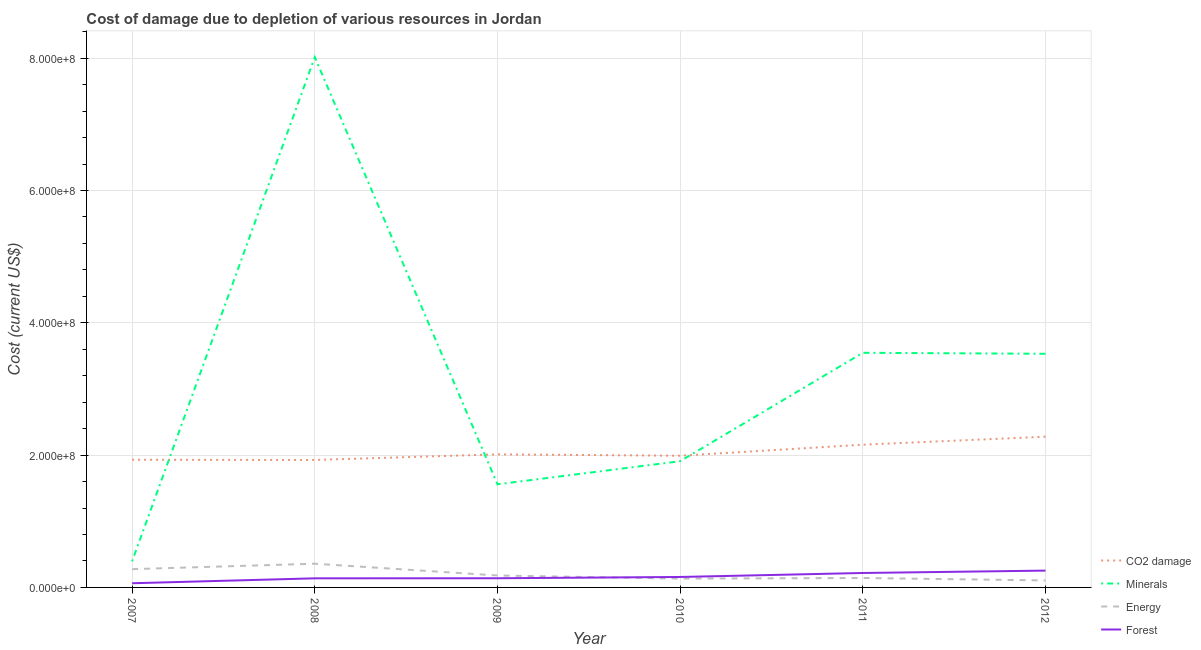Is the number of lines equal to the number of legend labels?
Your answer should be very brief. Yes. What is the cost of damage due to depletion of coal in 2010?
Keep it short and to the point. 1.99e+08. Across all years, what is the maximum cost of damage due to depletion of energy?
Your response must be concise. 3.58e+07. Across all years, what is the minimum cost of damage due to depletion of minerals?
Provide a succinct answer. 3.95e+07. What is the total cost of damage due to depletion of minerals in the graph?
Your answer should be very brief. 1.90e+09. What is the difference between the cost of damage due to depletion of forests in 2011 and that in 2012?
Provide a succinct answer. -3.59e+06. What is the difference between the cost of damage due to depletion of energy in 2009 and the cost of damage due to depletion of coal in 2008?
Provide a short and direct response. -1.75e+08. What is the average cost of damage due to depletion of minerals per year?
Provide a succinct answer. 3.16e+08. In the year 2010, what is the difference between the cost of damage due to depletion of energy and cost of damage due to depletion of coal?
Keep it short and to the point. -1.86e+08. In how many years, is the cost of damage due to depletion of energy greater than 360000000 US$?
Your response must be concise. 0. What is the ratio of the cost of damage due to depletion of energy in 2009 to that in 2012?
Offer a terse response. 1.71. Is the cost of damage due to depletion of minerals in 2009 less than that in 2010?
Offer a very short reply. Yes. Is the difference between the cost of damage due to depletion of coal in 2008 and 2011 greater than the difference between the cost of damage due to depletion of forests in 2008 and 2011?
Offer a very short reply. No. What is the difference between the highest and the second highest cost of damage due to depletion of forests?
Keep it short and to the point. 3.59e+06. What is the difference between the highest and the lowest cost of damage due to depletion of forests?
Your response must be concise. 1.91e+07. Is the sum of the cost of damage due to depletion of minerals in 2007 and 2009 greater than the maximum cost of damage due to depletion of coal across all years?
Give a very brief answer. No. Is the cost of damage due to depletion of energy strictly greater than the cost of damage due to depletion of coal over the years?
Your answer should be compact. No. Is the cost of damage due to depletion of minerals strictly less than the cost of damage due to depletion of forests over the years?
Offer a terse response. No. How many lines are there?
Ensure brevity in your answer.  4. Does the graph contain grids?
Provide a short and direct response. Yes. Where does the legend appear in the graph?
Ensure brevity in your answer.  Bottom right. How many legend labels are there?
Keep it short and to the point. 4. What is the title of the graph?
Provide a succinct answer. Cost of damage due to depletion of various resources in Jordan . What is the label or title of the X-axis?
Provide a short and direct response. Year. What is the label or title of the Y-axis?
Give a very brief answer. Cost (current US$). What is the Cost (current US$) in CO2 damage in 2007?
Ensure brevity in your answer.  1.93e+08. What is the Cost (current US$) of Minerals in 2007?
Provide a succinct answer. 3.95e+07. What is the Cost (current US$) of Energy in 2007?
Your answer should be very brief. 2.76e+07. What is the Cost (current US$) in Forest in 2007?
Provide a short and direct response. 6.30e+06. What is the Cost (current US$) of CO2 damage in 2008?
Your answer should be very brief. 1.93e+08. What is the Cost (current US$) of Minerals in 2008?
Your response must be concise. 8.02e+08. What is the Cost (current US$) of Energy in 2008?
Provide a short and direct response. 3.58e+07. What is the Cost (current US$) in Forest in 2008?
Offer a terse response. 1.38e+07. What is the Cost (current US$) in CO2 damage in 2009?
Ensure brevity in your answer.  2.01e+08. What is the Cost (current US$) of Minerals in 2009?
Provide a short and direct response. 1.56e+08. What is the Cost (current US$) in Energy in 2009?
Ensure brevity in your answer.  1.80e+07. What is the Cost (current US$) of Forest in 2009?
Your response must be concise. 1.39e+07. What is the Cost (current US$) in CO2 damage in 2010?
Keep it short and to the point. 1.99e+08. What is the Cost (current US$) of Minerals in 2010?
Offer a terse response. 1.91e+08. What is the Cost (current US$) in Energy in 2010?
Provide a succinct answer. 1.33e+07. What is the Cost (current US$) in Forest in 2010?
Provide a succinct answer. 1.58e+07. What is the Cost (current US$) of CO2 damage in 2011?
Make the answer very short. 2.16e+08. What is the Cost (current US$) of Minerals in 2011?
Offer a very short reply. 3.55e+08. What is the Cost (current US$) of Energy in 2011?
Ensure brevity in your answer.  1.43e+07. What is the Cost (current US$) in Forest in 2011?
Provide a succinct answer. 2.18e+07. What is the Cost (current US$) of CO2 damage in 2012?
Give a very brief answer. 2.28e+08. What is the Cost (current US$) of Minerals in 2012?
Keep it short and to the point. 3.53e+08. What is the Cost (current US$) of Energy in 2012?
Your answer should be very brief. 1.06e+07. What is the Cost (current US$) in Forest in 2012?
Your answer should be very brief. 2.54e+07. Across all years, what is the maximum Cost (current US$) in CO2 damage?
Offer a terse response. 2.28e+08. Across all years, what is the maximum Cost (current US$) of Minerals?
Offer a terse response. 8.02e+08. Across all years, what is the maximum Cost (current US$) in Energy?
Offer a very short reply. 3.58e+07. Across all years, what is the maximum Cost (current US$) in Forest?
Make the answer very short. 2.54e+07. Across all years, what is the minimum Cost (current US$) in CO2 damage?
Make the answer very short. 1.93e+08. Across all years, what is the minimum Cost (current US$) of Minerals?
Offer a very short reply. 3.95e+07. Across all years, what is the minimum Cost (current US$) of Energy?
Provide a succinct answer. 1.06e+07. Across all years, what is the minimum Cost (current US$) of Forest?
Provide a short and direct response. 6.30e+06. What is the total Cost (current US$) in CO2 damage in the graph?
Make the answer very short. 1.23e+09. What is the total Cost (current US$) in Minerals in the graph?
Your response must be concise. 1.90e+09. What is the total Cost (current US$) of Energy in the graph?
Offer a terse response. 1.20e+08. What is the total Cost (current US$) in Forest in the graph?
Provide a succinct answer. 9.70e+07. What is the difference between the Cost (current US$) of CO2 damage in 2007 and that in 2008?
Provide a short and direct response. 3.33e+05. What is the difference between the Cost (current US$) in Minerals in 2007 and that in 2008?
Offer a terse response. -7.62e+08. What is the difference between the Cost (current US$) in Energy in 2007 and that in 2008?
Provide a succinct answer. -8.19e+06. What is the difference between the Cost (current US$) in Forest in 2007 and that in 2008?
Your answer should be compact. -7.45e+06. What is the difference between the Cost (current US$) of CO2 damage in 2007 and that in 2009?
Offer a very short reply. -8.16e+06. What is the difference between the Cost (current US$) in Minerals in 2007 and that in 2009?
Keep it short and to the point. -1.16e+08. What is the difference between the Cost (current US$) in Energy in 2007 and that in 2009?
Offer a terse response. 9.60e+06. What is the difference between the Cost (current US$) of Forest in 2007 and that in 2009?
Your answer should be very brief. -7.56e+06. What is the difference between the Cost (current US$) in CO2 damage in 2007 and that in 2010?
Provide a short and direct response. -6.07e+06. What is the difference between the Cost (current US$) in Minerals in 2007 and that in 2010?
Offer a terse response. -1.51e+08. What is the difference between the Cost (current US$) of Energy in 2007 and that in 2010?
Ensure brevity in your answer.  1.43e+07. What is the difference between the Cost (current US$) of Forest in 2007 and that in 2010?
Offer a terse response. -9.51e+06. What is the difference between the Cost (current US$) of CO2 damage in 2007 and that in 2011?
Ensure brevity in your answer.  -2.28e+07. What is the difference between the Cost (current US$) in Minerals in 2007 and that in 2011?
Your response must be concise. -3.15e+08. What is the difference between the Cost (current US$) in Energy in 2007 and that in 2011?
Your response must be concise. 1.34e+07. What is the difference between the Cost (current US$) of Forest in 2007 and that in 2011?
Keep it short and to the point. -1.55e+07. What is the difference between the Cost (current US$) in CO2 damage in 2007 and that in 2012?
Provide a short and direct response. -3.48e+07. What is the difference between the Cost (current US$) of Minerals in 2007 and that in 2012?
Ensure brevity in your answer.  -3.14e+08. What is the difference between the Cost (current US$) of Energy in 2007 and that in 2012?
Your response must be concise. 1.71e+07. What is the difference between the Cost (current US$) in Forest in 2007 and that in 2012?
Make the answer very short. -1.91e+07. What is the difference between the Cost (current US$) in CO2 damage in 2008 and that in 2009?
Offer a very short reply. -8.49e+06. What is the difference between the Cost (current US$) in Minerals in 2008 and that in 2009?
Provide a short and direct response. 6.46e+08. What is the difference between the Cost (current US$) of Energy in 2008 and that in 2009?
Your response must be concise. 1.78e+07. What is the difference between the Cost (current US$) in Forest in 2008 and that in 2009?
Ensure brevity in your answer.  -1.09e+05. What is the difference between the Cost (current US$) in CO2 damage in 2008 and that in 2010?
Your answer should be compact. -6.40e+06. What is the difference between the Cost (current US$) of Minerals in 2008 and that in 2010?
Your response must be concise. 6.11e+08. What is the difference between the Cost (current US$) of Energy in 2008 and that in 2010?
Ensure brevity in your answer.  2.25e+07. What is the difference between the Cost (current US$) of Forest in 2008 and that in 2010?
Your answer should be very brief. -2.06e+06. What is the difference between the Cost (current US$) in CO2 damage in 2008 and that in 2011?
Provide a short and direct response. -2.31e+07. What is the difference between the Cost (current US$) in Minerals in 2008 and that in 2011?
Ensure brevity in your answer.  4.47e+08. What is the difference between the Cost (current US$) of Energy in 2008 and that in 2011?
Make the answer very short. 2.16e+07. What is the difference between the Cost (current US$) in Forest in 2008 and that in 2011?
Your answer should be compact. -8.07e+06. What is the difference between the Cost (current US$) of CO2 damage in 2008 and that in 2012?
Provide a succinct answer. -3.52e+07. What is the difference between the Cost (current US$) in Minerals in 2008 and that in 2012?
Your answer should be compact. 4.48e+08. What is the difference between the Cost (current US$) of Energy in 2008 and that in 2012?
Ensure brevity in your answer.  2.53e+07. What is the difference between the Cost (current US$) in Forest in 2008 and that in 2012?
Make the answer very short. -1.17e+07. What is the difference between the Cost (current US$) in CO2 damage in 2009 and that in 2010?
Make the answer very short. 2.09e+06. What is the difference between the Cost (current US$) in Minerals in 2009 and that in 2010?
Provide a short and direct response. -3.49e+07. What is the difference between the Cost (current US$) of Energy in 2009 and that in 2010?
Offer a very short reply. 4.74e+06. What is the difference between the Cost (current US$) in Forest in 2009 and that in 2010?
Your answer should be very brief. -1.95e+06. What is the difference between the Cost (current US$) in CO2 damage in 2009 and that in 2011?
Offer a terse response. -1.46e+07. What is the difference between the Cost (current US$) in Minerals in 2009 and that in 2011?
Provide a succinct answer. -1.99e+08. What is the difference between the Cost (current US$) of Energy in 2009 and that in 2011?
Ensure brevity in your answer.  3.79e+06. What is the difference between the Cost (current US$) in Forest in 2009 and that in 2011?
Ensure brevity in your answer.  -7.96e+06. What is the difference between the Cost (current US$) in CO2 damage in 2009 and that in 2012?
Your answer should be very brief. -2.67e+07. What is the difference between the Cost (current US$) of Minerals in 2009 and that in 2012?
Ensure brevity in your answer.  -1.97e+08. What is the difference between the Cost (current US$) of Energy in 2009 and that in 2012?
Offer a terse response. 7.49e+06. What is the difference between the Cost (current US$) in Forest in 2009 and that in 2012?
Your response must be concise. -1.15e+07. What is the difference between the Cost (current US$) in CO2 damage in 2010 and that in 2011?
Provide a short and direct response. -1.67e+07. What is the difference between the Cost (current US$) of Minerals in 2010 and that in 2011?
Keep it short and to the point. -1.64e+08. What is the difference between the Cost (current US$) in Energy in 2010 and that in 2011?
Give a very brief answer. -9.54e+05. What is the difference between the Cost (current US$) in Forest in 2010 and that in 2011?
Give a very brief answer. -6.01e+06. What is the difference between the Cost (current US$) of CO2 damage in 2010 and that in 2012?
Keep it short and to the point. -2.88e+07. What is the difference between the Cost (current US$) of Minerals in 2010 and that in 2012?
Offer a terse response. -1.62e+08. What is the difference between the Cost (current US$) of Energy in 2010 and that in 2012?
Ensure brevity in your answer.  2.75e+06. What is the difference between the Cost (current US$) in Forest in 2010 and that in 2012?
Provide a short and direct response. -9.60e+06. What is the difference between the Cost (current US$) in CO2 damage in 2011 and that in 2012?
Provide a succinct answer. -1.21e+07. What is the difference between the Cost (current US$) of Minerals in 2011 and that in 2012?
Offer a very short reply. 1.52e+06. What is the difference between the Cost (current US$) in Energy in 2011 and that in 2012?
Your response must be concise. 3.71e+06. What is the difference between the Cost (current US$) of Forest in 2011 and that in 2012?
Offer a terse response. -3.59e+06. What is the difference between the Cost (current US$) in CO2 damage in 2007 and the Cost (current US$) in Minerals in 2008?
Your answer should be compact. -6.09e+08. What is the difference between the Cost (current US$) of CO2 damage in 2007 and the Cost (current US$) of Energy in 2008?
Offer a very short reply. 1.57e+08. What is the difference between the Cost (current US$) of CO2 damage in 2007 and the Cost (current US$) of Forest in 2008?
Provide a short and direct response. 1.79e+08. What is the difference between the Cost (current US$) of Minerals in 2007 and the Cost (current US$) of Energy in 2008?
Make the answer very short. 3.67e+06. What is the difference between the Cost (current US$) of Minerals in 2007 and the Cost (current US$) of Forest in 2008?
Provide a short and direct response. 2.58e+07. What is the difference between the Cost (current US$) of Energy in 2007 and the Cost (current US$) of Forest in 2008?
Provide a short and direct response. 1.39e+07. What is the difference between the Cost (current US$) in CO2 damage in 2007 and the Cost (current US$) in Minerals in 2009?
Your response must be concise. 3.71e+07. What is the difference between the Cost (current US$) of CO2 damage in 2007 and the Cost (current US$) of Energy in 2009?
Offer a terse response. 1.75e+08. What is the difference between the Cost (current US$) of CO2 damage in 2007 and the Cost (current US$) of Forest in 2009?
Provide a succinct answer. 1.79e+08. What is the difference between the Cost (current US$) of Minerals in 2007 and the Cost (current US$) of Energy in 2009?
Offer a very short reply. 2.15e+07. What is the difference between the Cost (current US$) of Minerals in 2007 and the Cost (current US$) of Forest in 2009?
Your answer should be compact. 2.57e+07. What is the difference between the Cost (current US$) in Energy in 2007 and the Cost (current US$) in Forest in 2009?
Your answer should be compact. 1.38e+07. What is the difference between the Cost (current US$) in CO2 damage in 2007 and the Cost (current US$) in Minerals in 2010?
Provide a succinct answer. 2.23e+06. What is the difference between the Cost (current US$) in CO2 damage in 2007 and the Cost (current US$) in Energy in 2010?
Offer a terse response. 1.80e+08. What is the difference between the Cost (current US$) in CO2 damage in 2007 and the Cost (current US$) in Forest in 2010?
Offer a very short reply. 1.77e+08. What is the difference between the Cost (current US$) in Minerals in 2007 and the Cost (current US$) in Energy in 2010?
Provide a succinct answer. 2.62e+07. What is the difference between the Cost (current US$) of Minerals in 2007 and the Cost (current US$) of Forest in 2010?
Your answer should be compact. 2.37e+07. What is the difference between the Cost (current US$) in Energy in 2007 and the Cost (current US$) in Forest in 2010?
Keep it short and to the point. 1.18e+07. What is the difference between the Cost (current US$) in CO2 damage in 2007 and the Cost (current US$) in Minerals in 2011?
Provide a short and direct response. -1.62e+08. What is the difference between the Cost (current US$) in CO2 damage in 2007 and the Cost (current US$) in Energy in 2011?
Your answer should be compact. 1.79e+08. What is the difference between the Cost (current US$) of CO2 damage in 2007 and the Cost (current US$) of Forest in 2011?
Provide a succinct answer. 1.71e+08. What is the difference between the Cost (current US$) in Minerals in 2007 and the Cost (current US$) in Energy in 2011?
Your answer should be very brief. 2.53e+07. What is the difference between the Cost (current US$) in Minerals in 2007 and the Cost (current US$) in Forest in 2011?
Offer a very short reply. 1.77e+07. What is the difference between the Cost (current US$) of Energy in 2007 and the Cost (current US$) of Forest in 2011?
Give a very brief answer. 5.82e+06. What is the difference between the Cost (current US$) in CO2 damage in 2007 and the Cost (current US$) in Minerals in 2012?
Offer a very short reply. -1.60e+08. What is the difference between the Cost (current US$) of CO2 damage in 2007 and the Cost (current US$) of Energy in 2012?
Your response must be concise. 1.82e+08. What is the difference between the Cost (current US$) in CO2 damage in 2007 and the Cost (current US$) in Forest in 2012?
Give a very brief answer. 1.68e+08. What is the difference between the Cost (current US$) in Minerals in 2007 and the Cost (current US$) in Energy in 2012?
Your answer should be compact. 2.90e+07. What is the difference between the Cost (current US$) in Minerals in 2007 and the Cost (current US$) in Forest in 2012?
Offer a terse response. 1.41e+07. What is the difference between the Cost (current US$) of Energy in 2007 and the Cost (current US$) of Forest in 2012?
Give a very brief answer. 2.24e+06. What is the difference between the Cost (current US$) in CO2 damage in 2008 and the Cost (current US$) in Minerals in 2009?
Your answer should be very brief. 3.68e+07. What is the difference between the Cost (current US$) of CO2 damage in 2008 and the Cost (current US$) of Energy in 2009?
Offer a terse response. 1.75e+08. What is the difference between the Cost (current US$) in CO2 damage in 2008 and the Cost (current US$) in Forest in 2009?
Make the answer very short. 1.79e+08. What is the difference between the Cost (current US$) in Minerals in 2008 and the Cost (current US$) in Energy in 2009?
Keep it short and to the point. 7.83e+08. What is the difference between the Cost (current US$) in Minerals in 2008 and the Cost (current US$) in Forest in 2009?
Give a very brief answer. 7.88e+08. What is the difference between the Cost (current US$) of Energy in 2008 and the Cost (current US$) of Forest in 2009?
Keep it short and to the point. 2.20e+07. What is the difference between the Cost (current US$) in CO2 damage in 2008 and the Cost (current US$) in Minerals in 2010?
Provide a short and direct response. 1.89e+06. What is the difference between the Cost (current US$) in CO2 damage in 2008 and the Cost (current US$) in Energy in 2010?
Ensure brevity in your answer.  1.79e+08. What is the difference between the Cost (current US$) in CO2 damage in 2008 and the Cost (current US$) in Forest in 2010?
Ensure brevity in your answer.  1.77e+08. What is the difference between the Cost (current US$) of Minerals in 2008 and the Cost (current US$) of Energy in 2010?
Your answer should be compact. 7.88e+08. What is the difference between the Cost (current US$) in Minerals in 2008 and the Cost (current US$) in Forest in 2010?
Keep it short and to the point. 7.86e+08. What is the difference between the Cost (current US$) in Energy in 2008 and the Cost (current US$) in Forest in 2010?
Ensure brevity in your answer.  2.00e+07. What is the difference between the Cost (current US$) of CO2 damage in 2008 and the Cost (current US$) of Minerals in 2011?
Ensure brevity in your answer.  -1.62e+08. What is the difference between the Cost (current US$) in CO2 damage in 2008 and the Cost (current US$) in Energy in 2011?
Provide a short and direct response. 1.78e+08. What is the difference between the Cost (current US$) in CO2 damage in 2008 and the Cost (current US$) in Forest in 2011?
Give a very brief answer. 1.71e+08. What is the difference between the Cost (current US$) in Minerals in 2008 and the Cost (current US$) in Energy in 2011?
Keep it short and to the point. 7.87e+08. What is the difference between the Cost (current US$) in Minerals in 2008 and the Cost (current US$) in Forest in 2011?
Offer a terse response. 7.80e+08. What is the difference between the Cost (current US$) of Energy in 2008 and the Cost (current US$) of Forest in 2011?
Offer a very short reply. 1.40e+07. What is the difference between the Cost (current US$) in CO2 damage in 2008 and the Cost (current US$) in Minerals in 2012?
Give a very brief answer. -1.60e+08. What is the difference between the Cost (current US$) of CO2 damage in 2008 and the Cost (current US$) of Energy in 2012?
Provide a short and direct response. 1.82e+08. What is the difference between the Cost (current US$) of CO2 damage in 2008 and the Cost (current US$) of Forest in 2012?
Your answer should be very brief. 1.67e+08. What is the difference between the Cost (current US$) of Minerals in 2008 and the Cost (current US$) of Energy in 2012?
Your answer should be compact. 7.91e+08. What is the difference between the Cost (current US$) in Minerals in 2008 and the Cost (current US$) in Forest in 2012?
Provide a short and direct response. 7.76e+08. What is the difference between the Cost (current US$) of Energy in 2008 and the Cost (current US$) of Forest in 2012?
Your answer should be very brief. 1.04e+07. What is the difference between the Cost (current US$) in CO2 damage in 2009 and the Cost (current US$) in Minerals in 2010?
Provide a succinct answer. 1.04e+07. What is the difference between the Cost (current US$) of CO2 damage in 2009 and the Cost (current US$) of Energy in 2010?
Offer a very short reply. 1.88e+08. What is the difference between the Cost (current US$) in CO2 damage in 2009 and the Cost (current US$) in Forest in 2010?
Your answer should be compact. 1.85e+08. What is the difference between the Cost (current US$) in Minerals in 2009 and the Cost (current US$) in Energy in 2010?
Offer a terse response. 1.43e+08. What is the difference between the Cost (current US$) in Minerals in 2009 and the Cost (current US$) in Forest in 2010?
Offer a terse response. 1.40e+08. What is the difference between the Cost (current US$) of Energy in 2009 and the Cost (current US$) of Forest in 2010?
Ensure brevity in your answer.  2.23e+06. What is the difference between the Cost (current US$) in CO2 damage in 2009 and the Cost (current US$) in Minerals in 2011?
Keep it short and to the point. -1.54e+08. What is the difference between the Cost (current US$) in CO2 damage in 2009 and the Cost (current US$) in Energy in 2011?
Give a very brief answer. 1.87e+08. What is the difference between the Cost (current US$) of CO2 damage in 2009 and the Cost (current US$) of Forest in 2011?
Offer a very short reply. 1.79e+08. What is the difference between the Cost (current US$) in Minerals in 2009 and the Cost (current US$) in Energy in 2011?
Ensure brevity in your answer.  1.42e+08. What is the difference between the Cost (current US$) in Minerals in 2009 and the Cost (current US$) in Forest in 2011?
Give a very brief answer. 1.34e+08. What is the difference between the Cost (current US$) of Energy in 2009 and the Cost (current US$) of Forest in 2011?
Your answer should be compact. -3.78e+06. What is the difference between the Cost (current US$) of CO2 damage in 2009 and the Cost (current US$) of Minerals in 2012?
Offer a terse response. -1.52e+08. What is the difference between the Cost (current US$) of CO2 damage in 2009 and the Cost (current US$) of Energy in 2012?
Keep it short and to the point. 1.91e+08. What is the difference between the Cost (current US$) in CO2 damage in 2009 and the Cost (current US$) in Forest in 2012?
Your answer should be compact. 1.76e+08. What is the difference between the Cost (current US$) in Minerals in 2009 and the Cost (current US$) in Energy in 2012?
Make the answer very short. 1.45e+08. What is the difference between the Cost (current US$) in Minerals in 2009 and the Cost (current US$) in Forest in 2012?
Keep it short and to the point. 1.30e+08. What is the difference between the Cost (current US$) of Energy in 2009 and the Cost (current US$) of Forest in 2012?
Your answer should be very brief. -7.36e+06. What is the difference between the Cost (current US$) of CO2 damage in 2010 and the Cost (current US$) of Minerals in 2011?
Offer a terse response. -1.56e+08. What is the difference between the Cost (current US$) of CO2 damage in 2010 and the Cost (current US$) of Energy in 2011?
Offer a very short reply. 1.85e+08. What is the difference between the Cost (current US$) of CO2 damage in 2010 and the Cost (current US$) of Forest in 2011?
Your response must be concise. 1.77e+08. What is the difference between the Cost (current US$) in Minerals in 2010 and the Cost (current US$) in Energy in 2011?
Your answer should be compact. 1.76e+08. What is the difference between the Cost (current US$) of Minerals in 2010 and the Cost (current US$) of Forest in 2011?
Provide a short and direct response. 1.69e+08. What is the difference between the Cost (current US$) in Energy in 2010 and the Cost (current US$) in Forest in 2011?
Provide a short and direct response. -8.52e+06. What is the difference between the Cost (current US$) in CO2 damage in 2010 and the Cost (current US$) in Minerals in 2012?
Give a very brief answer. -1.54e+08. What is the difference between the Cost (current US$) of CO2 damage in 2010 and the Cost (current US$) of Energy in 2012?
Keep it short and to the point. 1.88e+08. What is the difference between the Cost (current US$) in CO2 damage in 2010 and the Cost (current US$) in Forest in 2012?
Your response must be concise. 1.74e+08. What is the difference between the Cost (current US$) of Minerals in 2010 and the Cost (current US$) of Energy in 2012?
Provide a short and direct response. 1.80e+08. What is the difference between the Cost (current US$) in Minerals in 2010 and the Cost (current US$) in Forest in 2012?
Ensure brevity in your answer.  1.65e+08. What is the difference between the Cost (current US$) in Energy in 2010 and the Cost (current US$) in Forest in 2012?
Offer a very short reply. -1.21e+07. What is the difference between the Cost (current US$) in CO2 damage in 2011 and the Cost (current US$) in Minerals in 2012?
Provide a succinct answer. -1.37e+08. What is the difference between the Cost (current US$) in CO2 damage in 2011 and the Cost (current US$) in Energy in 2012?
Your response must be concise. 2.05e+08. What is the difference between the Cost (current US$) of CO2 damage in 2011 and the Cost (current US$) of Forest in 2012?
Ensure brevity in your answer.  1.90e+08. What is the difference between the Cost (current US$) in Minerals in 2011 and the Cost (current US$) in Energy in 2012?
Provide a succinct answer. 3.44e+08. What is the difference between the Cost (current US$) of Minerals in 2011 and the Cost (current US$) of Forest in 2012?
Your answer should be very brief. 3.29e+08. What is the difference between the Cost (current US$) of Energy in 2011 and the Cost (current US$) of Forest in 2012?
Make the answer very short. -1.11e+07. What is the average Cost (current US$) in CO2 damage per year?
Your answer should be compact. 2.05e+08. What is the average Cost (current US$) of Minerals per year?
Offer a very short reply. 3.16e+08. What is the average Cost (current US$) of Energy per year?
Offer a terse response. 1.99e+07. What is the average Cost (current US$) in Forest per year?
Offer a terse response. 1.62e+07. In the year 2007, what is the difference between the Cost (current US$) in CO2 damage and Cost (current US$) in Minerals?
Your answer should be very brief. 1.53e+08. In the year 2007, what is the difference between the Cost (current US$) in CO2 damage and Cost (current US$) in Energy?
Offer a very short reply. 1.65e+08. In the year 2007, what is the difference between the Cost (current US$) in CO2 damage and Cost (current US$) in Forest?
Your response must be concise. 1.87e+08. In the year 2007, what is the difference between the Cost (current US$) in Minerals and Cost (current US$) in Energy?
Give a very brief answer. 1.19e+07. In the year 2007, what is the difference between the Cost (current US$) of Minerals and Cost (current US$) of Forest?
Your answer should be very brief. 3.32e+07. In the year 2007, what is the difference between the Cost (current US$) in Energy and Cost (current US$) in Forest?
Keep it short and to the point. 2.13e+07. In the year 2008, what is the difference between the Cost (current US$) of CO2 damage and Cost (current US$) of Minerals?
Provide a short and direct response. -6.09e+08. In the year 2008, what is the difference between the Cost (current US$) in CO2 damage and Cost (current US$) in Energy?
Make the answer very short. 1.57e+08. In the year 2008, what is the difference between the Cost (current US$) of CO2 damage and Cost (current US$) of Forest?
Your answer should be compact. 1.79e+08. In the year 2008, what is the difference between the Cost (current US$) in Minerals and Cost (current US$) in Energy?
Provide a succinct answer. 7.66e+08. In the year 2008, what is the difference between the Cost (current US$) in Minerals and Cost (current US$) in Forest?
Offer a terse response. 7.88e+08. In the year 2008, what is the difference between the Cost (current US$) of Energy and Cost (current US$) of Forest?
Offer a very short reply. 2.21e+07. In the year 2009, what is the difference between the Cost (current US$) in CO2 damage and Cost (current US$) in Minerals?
Offer a very short reply. 4.53e+07. In the year 2009, what is the difference between the Cost (current US$) in CO2 damage and Cost (current US$) in Energy?
Provide a short and direct response. 1.83e+08. In the year 2009, what is the difference between the Cost (current US$) in CO2 damage and Cost (current US$) in Forest?
Your response must be concise. 1.87e+08. In the year 2009, what is the difference between the Cost (current US$) in Minerals and Cost (current US$) in Energy?
Your response must be concise. 1.38e+08. In the year 2009, what is the difference between the Cost (current US$) in Minerals and Cost (current US$) in Forest?
Provide a short and direct response. 1.42e+08. In the year 2009, what is the difference between the Cost (current US$) in Energy and Cost (current US$) in Forest?
Provide a succinct answer. 4.19e+06. In the year 2010, what is the difference between the Cost (current US$) in CO2 damage and Cost (current US$) in Minerals?
Offer a very short reply. 8.30e+06. In the year 2010, what is the difference between the Cost (current US$) in CO2 damage and Cost (current US$) in Energy?
Your answer should be very brief. 1.86e+08. In the year 2010, what is the difference between the Cost (current US$) in CO2 damage and Cost (current US$) in Forest?
Make the answer very short. 1.83e+08. In the year 2010, what is the difference between the Cost (current US$) in Minerals and Cost (current US$) in Energy?
Keep it short and to the point. 1.77e+08. In the year 2010, what is the difference between the Cost (current US$) of Minerals and Cost (current US$) of Forest?
Provide a short and direct response. 1.75e+08. In the year 2010, what is the difference between the Cost (current US$) in Energy and Cost (current US$) in Forest?
Your answer should be very brief. -2.51e+06. In the year 2011, what is the difference between the Cost (current US$) of CO2 damage and Cost (current US$) of Minerals?
Provide a succinct answer. -1.39e+08. In the year 2011, what is the difference between the Cost (current US$) of CO2 damage and Cost (current US$) of Energy?
Offer a terse response. 2.01e+08. In the year 2011, what is the difference between the Cost (current US$) in CO2 damage and Cost (current US$) in Forest?
Provide a succinct answer. 1.94e+08. In the year 2011, what is the difference between the Cost (current US$) in Minerals and Cost (current US$) in Energy?
Ensure brevity in your answer.  3.40e+08. In the year 2011, what is the difference between the Cost (current US$) in Minerals and Cost (current US$) in Forest?
Offer a very short reply. 3.33e+08. In the year 2011, what is the difference between the Cost (current US$) in Energy and Cost (current US$) in Forest?
Your answer should be compact. -7.56e+06. In the year 2012, what is the difference between the Cost (current US$) of CO2 damage and Cost (current US$) of Minerals?
Your answer should be very brief. -1.25e+08. In the year 2012, what is the difference between the Cost (current US$) of CO2 damage and Cost (current US$) of Energy?
Your answer should be very brief. 2.17e+08. In the year 2012, what is the difference between the Cost (current US$) in CO2 damage and Cost (current US$) in Forest?
Your answer should be very brief. 2.02e+08. In the year 2012, what is the difference between the Cost (current US$) of Minerals and Cost (current US$) of Energy?
Keep it short and to the point. 3.43e+08. In the year 2012, what is the difference between the Cost (current US$) of Minerals and Cost (current US$) of Forest?
Your response must be concise. 3.28e+08. In the year 2012, what is the difference between the Cost (current US$) in Energy and Cost (current US$) in Forest?
Your answer should be compact. -1.49e+07. What is the ratio of the Cost (current US$) of CO2 damage in 2007 to that in 2008?
Provide a short and direct response. 1. What is the ratio of the Cost (current US$) in Minerals in 2007 to that in 2008?
Provide a short and direct response. 0.05. What is the ratio of the Cost (current US$) in Energy in 2007 to that in 2008?
Offer a very short reply. 0.77. What is the ratio of the Cost (current US$) of Forest in 2007 to that in 2008?
Your response must be concise. 0.46. What is the ratio of the Cost (current US$) of CO2 damage in 2007 to that in 2009?
Offer a terse response. 0.96. What is the ratio of the Cost (current US$) of Minerals in 2007 to that in 2009?
Offer a terse response. 0.25. What is the ratio of the Cost (current US$) in Energy in 2007 to that in 2009?
Provide a short and direct response. 1.53. What is the ratio of the Cost (current US$) of Forest in 2007 to that in 2009?
Keep it short and to the point. 0.45. What is the ratio of the Cost (current US$) of CO2 damage in 2007 to that in 2010?
Provide a short and direct response. 0.97. What is the ratio of the Cost (current US$) of Minerals in 2007 to that in 2010?
Ensure brevity in your answer.  0.21. What is the ratio of the Cost (current US$) of Energy in 2007 to that in 2010?
Ensure brevity in your answer.  2.08. What is the ratio of the Cost (current US$) of Forest in 2007 to that in 2010?
Make the answer very short. 0.4. What is the ratio of the Cost (current US$) in CO2 damage in 2007 to that in 2011?
Make the answer very short. 0.89. What is the ratio of the Cost (current US$) of Minerals in 2007 to that in 2011?
Provide a short and direct response. 0.11. What is the ratio of the Cost (current US$) of Energy in 2007 to that in 2011?
Ensure brevity in your answer.  1.94. What is the ratio of the Cost (current US$) in Forest in 2007 to that in 2011?
Your response must be concise. 0.29. What is the ratio of the Cost (current US$) of CO2 damage in 2007 to that in 2012?
Your answer should be compact. 0.85. What is the ratio of the Cost (current US$) of Minerals in 2007 to that in 2012?
Your answer should be compact. 0.11. What is the ratio of the Cost (current US$) of Energy in 2007 to that in 2012?
Your answer should be very brief. 2.62. What is the ratio of the Cost (current US$) of Forest in 2007 to that in 2012?
Provide a short and direct response. 0.25. What is the ratio of the Cost (current US$) in CO2 damage in 2008 to that in 2009?
Offer a very short reply. 0.96. What is the ratio of the Cost (current US$) in Minerals in 2008 to that in 2009?
Your answer should be very brief. 5.14. What is the ratio of the Cost (current US$) of Energy in 2008 to that in 2009?
Ensure brevity in your answer.  1.99. What is the ratio of the Cost (current US$) of CO2 damage in 2008 to that in 2010?
Offer a terse response. 0.97. What is the ratio of the Cost (current US$) in Minerals in 2008 to that in 2010?
Your response must be concise. 4.2. What is the ratio of the Cost (current US$) of Energy in 2008 to that in 2010?
Your response must be concise. 2.69. What is the ratio of the Cost (current US$) in Forest in 2008 to that in 2010?
Ensure brevity in your answer.  0.87. What is the ratio of the Cost (current US$) in CO2 damage in 2008 to that in 2011?
Ensure brevity in your answer.  0.89. What is the ratio of the Cost (current US$) of Minerals in 2008 to that in 2011?
Give a very brief answer. 2.26. What is the ratio of the Cost (current US$) of Energy in 2008 to that in 2011?
Offer a terse response. 2.51. What is the ratio of the Cost (current US$) of Forest in 2008 to that in 2011?
Your response must be concise. 0.63. What is the ratio of the Cost (current US$) in CO2 damage in 2008 to that in 2012?
Offer a very short reply. 0.85. What is the ratio of the Cost (current US$) in Minerals in 2008 to that in 2012?
Your answer should be compact. 2.27. What is the ratio of the Cost (current US$) of Energy in 2008 to that in 2012?
Ensure brevity in your answer.  3.4. What is the ratio of the Cost (current US$) of Forest in 2008 to that in 2012?
Give a very brief answer. 0.54. What is the ratio of the Cost (current US$) of CO2 damage in 2009 to that in 2010?
Give a very brief answer. 1.01. What is the ratio of the Cost (current US$) in Minerals in 2009 to that in 2010?
Your answer should be very brief. 0.82. What is the ratio of the Cost (current US$) in Energy in 2009 to that in 2010?
Your response must be concise. 1.36. What is the ratio of the Cost (current US$) of Forest in 2009 to that in 2010?
Your answer should be very brief. 0.88. What is the ratio of the Cost (current US$) in CO2 damage in 2009 to that in 2011?
Offer a terse response. 0.93. What is the ratio of the Cost (current US$) of Minerals in 2009 to that in 2011?
Keep it short and to the point. 0.44. What is the ratio of the Cost (current US$) of Energy in 2009 to that in 2011?
Your answer should be very brief. 1.27. What is the ratio of the Cost (current US$) of Forest in 2009 to that in 2011?
Your response must be concise. 0.64. What is the ratio of the Cost (current US$) of CO2 damage in 2009 to that in 2012?
Offer a very short reply. 0.88. What is the ratio of the Cost (current US$) of Minerals in 2009 to that in 2012?
Your answer should be very brief. 0.44. What is the ratio of the Cost (current US$) of Energy in 2009 to that in 2012?
Your answer should be compact. 1.71. What is the ratio of the Cost (current US$) of Forest in 2009 to that in 2012?
Your response must be concise. 0.55. What is the ratio of the Cost (current US$) in CO2 damage in 2010 to that in 2011?
Keep it short and to the point. 0.92. What is the ratio of the Cost (current US$) in Minerals in 2010 to that in 2011?
Give a very brief answer. 0.54. What is the ratio of the Cost (current US$) of Energy in 2010 to that in 2011?
Provide a succinct answer. 0.93. What is the ratio of the Cost (current US$) in Forest in 2010 to that in 2011?
Provide a short and direct response. 0.72. What is the ratio of the Cost (current US$) of CO2 damage in 2010 to that in 2012?
Offer a very short reply. 0.87. What is the ratio of the Cost (current US$) in Minerals in 2010 to that in 2012?
Offer a very short reply. 0.54. What is the ratio of the Cost (current US$) of Energy in 2010 to that in 2012?
Your response must be concise. 1.26. What is the ratio of the Cost (current US$) of Forest in 2010 to that in 2012?
Ensure brevity in your answer.  0.62. What is the ratio of the Cost (current US$) of CO2 damage in 2011 to that in 2012?
Offer a very short reply. 0.95. What is the ratio of the Cost (current US$) in Minerals in 2011 to that in 2012?
Your answer should be compact. 1. What is the ratio of the Cost (current US$) in Energy in 2011 to that in 2012?
Ensure brevity in your answer.  1.35. What is the ratio of the Cost (current US$) in Forest in 2011 to that in 2012?
Provide a short and direct response. 0.86. What is the difference between the highest and the second highest Cost (current US$) of CO2 damage?
Your response must be concise. 1.21e+07. What is the difference between the highest and the second highest Cost (current US$) of Minerals?
Make the answer very short. 4.47e+08. What is the difference between the highest and the second highest Cost (current US$) of Energy?
Your answer should be compact. 8.19e+06. What is the difference between the highest and the second highest Cost (current US$) in Forest?
Offer a terse response. 3.59e+06. What is the difference between the highest and the lowest Cost (current US$) of CO2 damage?
Make the answer very short. 3.52e+07. What is the difference between the highest and the lowest Cost (current US$) in Minerals?
Ensure brevity in your answer.  7.62e+08. What is the difference between the highest and the lowest Cost (current US$) in Energy?
Provide a succinct answer. 2.53e+07. What is the difference between the highest and the lowest Cost (current US$) of Forest?
Offer a very short reply. 1.91e+07. 